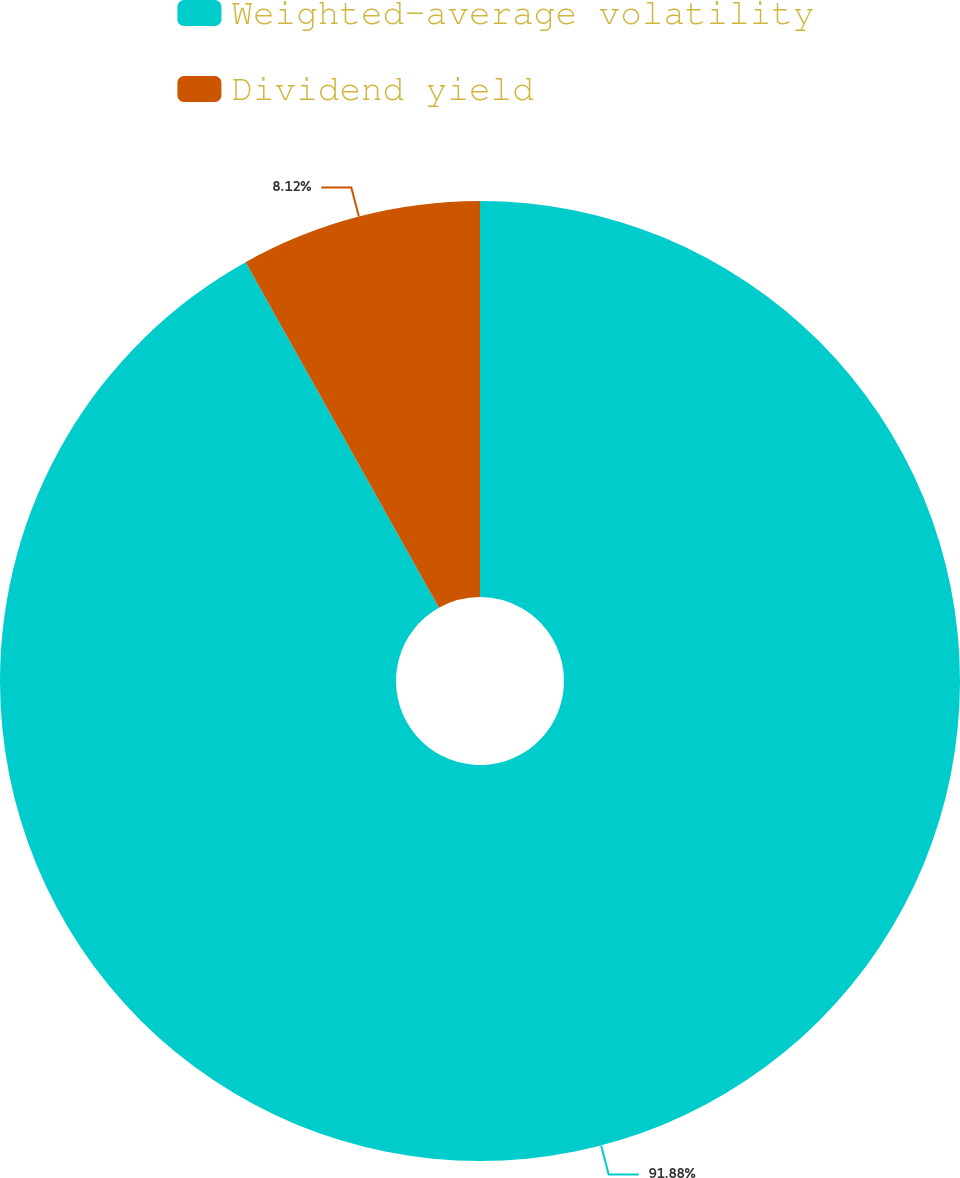Convert chart. <chart><loc_0><loc_0><loc_500><loc_500><pie_chart><fcel>Weighted-average volatility<fcel>Dividend yield<nl><fcel>91.88%<fcel>8.12%<nl></chart> 